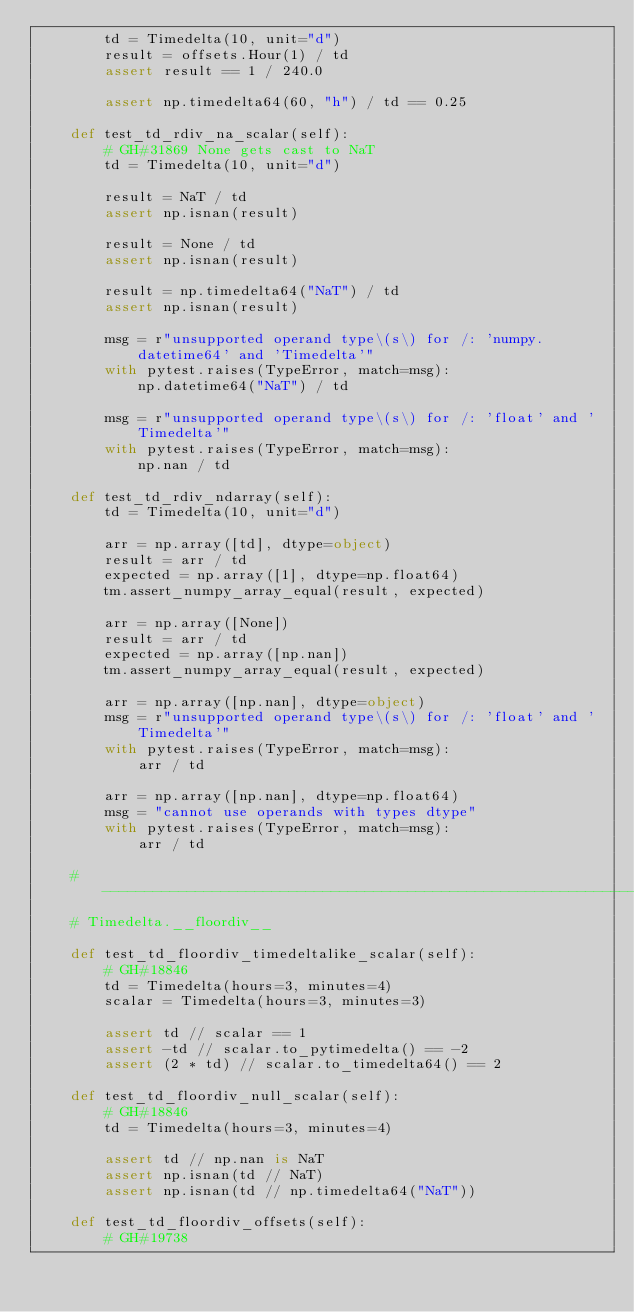<code> <loc_0><loc_0><loc_500><loc_500><_Python_>        td = Timedelta(10, unit="d")
        result = offsets.Hour(1) / td
        assert result == 1 / 240.0

        assert np.timedelta64(60, "h") / td == 0.25

    def test_td_rdiv_na_scalar(self):
        # GH#31869 None gets cast to NaT
        td = Timedelta(10, unit="d")

        result = NaT / td
        assert np.isnan(result)

        result = None / td
        assert np.isnan(result)

        result = np.timedelta64("NaT") / td
        assert np.isnan(result)

        msg = r"unsupported operand type\(s\) for /: 'numpy.datetime64' and 'Timedelta'"
        with pytest.raises(TypeError, match=msg):
            np.datetime64("NaT") / td

        msg = r"unsupported operand type\(s\) for /: 'float' and 'Timedelta'"
        with pytest.raises(TypeError, match=msg):
            np.nan / td

    def test_td_rdiv_ndarray(self):
        td = Timedelta(10, unit="d")

        arr = np.array([td], dtype=object)
        result = arr / td
        expected = np.array([1], dtype=np.float64)
        tm.assert_numpy_array_equal(result, expected)

        arr = np.array([None])
        result = arr / td
        expected = np.array([np.nan])
        tm.assert_numpy_array_equal(result, expected)

        arr = np.array([np.nan], dtype=object)
        msg = r"unsupported operand type\(s\) for /: 'float' and 'Timedelta'"
        with pytest.raises(TypeError, match=msg):
            arr / td

        arr = np.array([np.nan], dtype=np.float64)
        msg = "cannot use operands with types dtype"
        with pytest.raises(TypeError, match=msg):
            arr / td

    # ---------------------------------------------------------------
    # Timedelta.__floordiv__

    def test_td_floordiv_timedeltalike_scalar(self):
        # GH#18846
        td = Timedelta(hours=3, minutes=4)
        scalar = Timedelta(hours=3, minutes=3)

        assert td // scalar == 1
        assert -td // scalar.to_pytimedelta() == -2
        assert (2 * td) // scalar.to_timedelta64() == 2

    def test_td_floordiv_null_scalar(self):
        # GH#18846
        td = Timedelta(hours=3, minutes=4)

        assert td // np.nan is NaT
        assert np.isnan(td // NaT)
        assert np.isnan(td // np.timedelta64("NaT"))

    def test_td_floordiv_offsets(self):
        # GH#19738</code> 